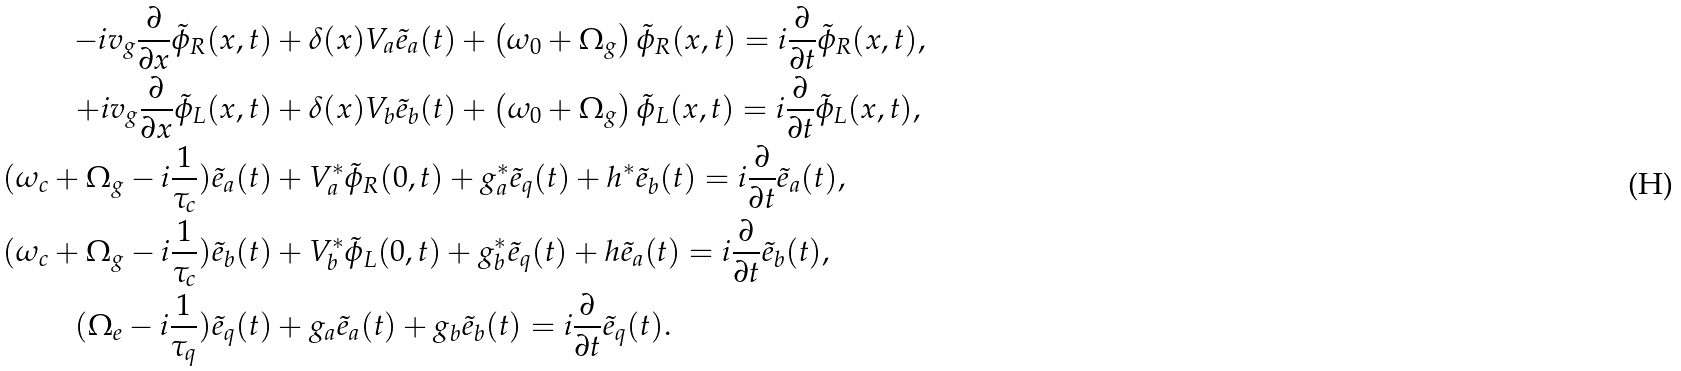<formula> <loc_0><loc_0><loc_500><loc_500>- i v _ { g } \frac { \partial } { \partial x } \tilde { \phi } _ { R } ( x , t ) & + \delta ( x ) V _ { a } \tilde { e } _ { a } ( t ) + \left ( \omega _ { 0 } + \Omega _ { g } \right ) \tilde { \phi } _ { R } ( x , t ) = i \frac { \partial } { \partial t } \tilde { \phi } _ { R } ( x , t ) , \\ + i v _ { g } \frac { \partial } { \partial x } \tilde { \phi } _ { L } ( x , t ) & + \delta ( x ) V _ { b } \tilde { e } _ { b } ( t ) + \left ( \omega _ { 0 } + \Omega _ { g } \right ) \tilde { \phi } _ { L } ( x , t ) = i \frac { \partial } { \partial t } \tilde { \phi } _ { L } ( x , t ) , \\ ( \omega _ { c } + \Omega _ { g } - i \frac { 1 } { \tau _ { c } } ) \tilde { e } _ { a } ( t ) & + V _ { a } ^ { * } \tilde { \phi } _ { R } ( 0 , t ) + g _ { a } ^ { * } \tilde { e } _ { q } ( t ) + h ^ { * } \tilde { e } _ { b } ( t ) = i \frac { \partial } { \partial t } \tilde { e } _ { a } ( t ) , \\ ( \omega _ { c } + \Omega _ { g } - i \frac { 1 } { \tau _ { c } } ) \tilde { e } _ { b } ( t ) & + V _ { b } ^ { * } \tilde { \phi } _ { L } ( 0 , t ) + g _ { b } ^ { * } \tilde { e } _ { q } ( t ) + h \tilde { e } _ { a } ( t ) = i \frac { \partial } { \partial t } \tilde { e } _ { b } ( t ) , \\ ( \Omega _ { e } - i \frac { 1 } { \tau _ { q } } ) \tilde { e } _ { q } ( t ) & + g _ { a } \tilde { e } _ { a } ( t ) + g _ { b } \tilde { e } _ { b } ( t ) = i \frac { \partial } { \partial t } \tilde { e } _ { q } ( t ) .</formula> 